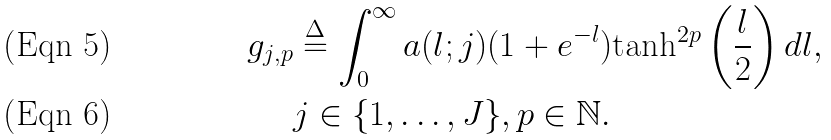<formula> <loc_0><loc_0><loc_500><loc_500>g _ { j , p } & \overset { \Delta } { = } \int _ { 0 } ^ { \infty } a ( l ; j ) ( 1 + e ^ { - l } ) \text {tanh} ^ { 2 p } \left ( \frac { l } { 2 } \right ) d l , \\ & j \in \{ 1 , \hdots , J \} , p \in \mathbb { N } .</formula> 